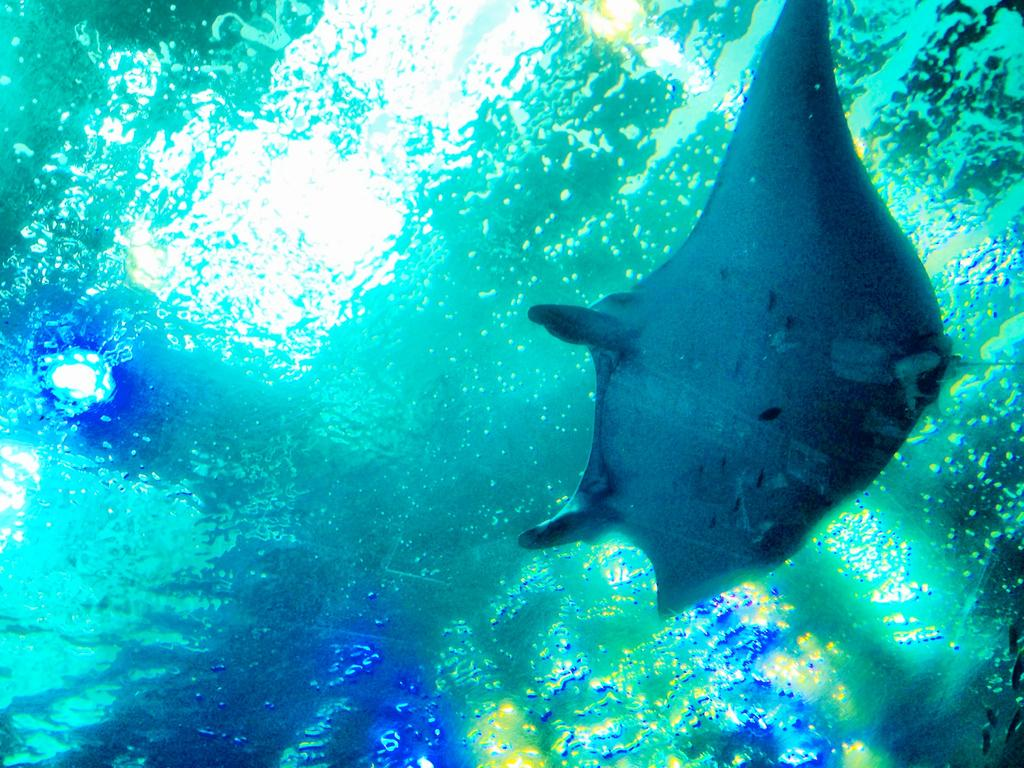What type of animal is in the image? There is a sea animal in the image. Where is the sea animal located? The sea animal is in the water. What letters are being used to spell out the name of the bear in the image? There is no bear present in the image, and therefore no letters are being used to spell out its name. 